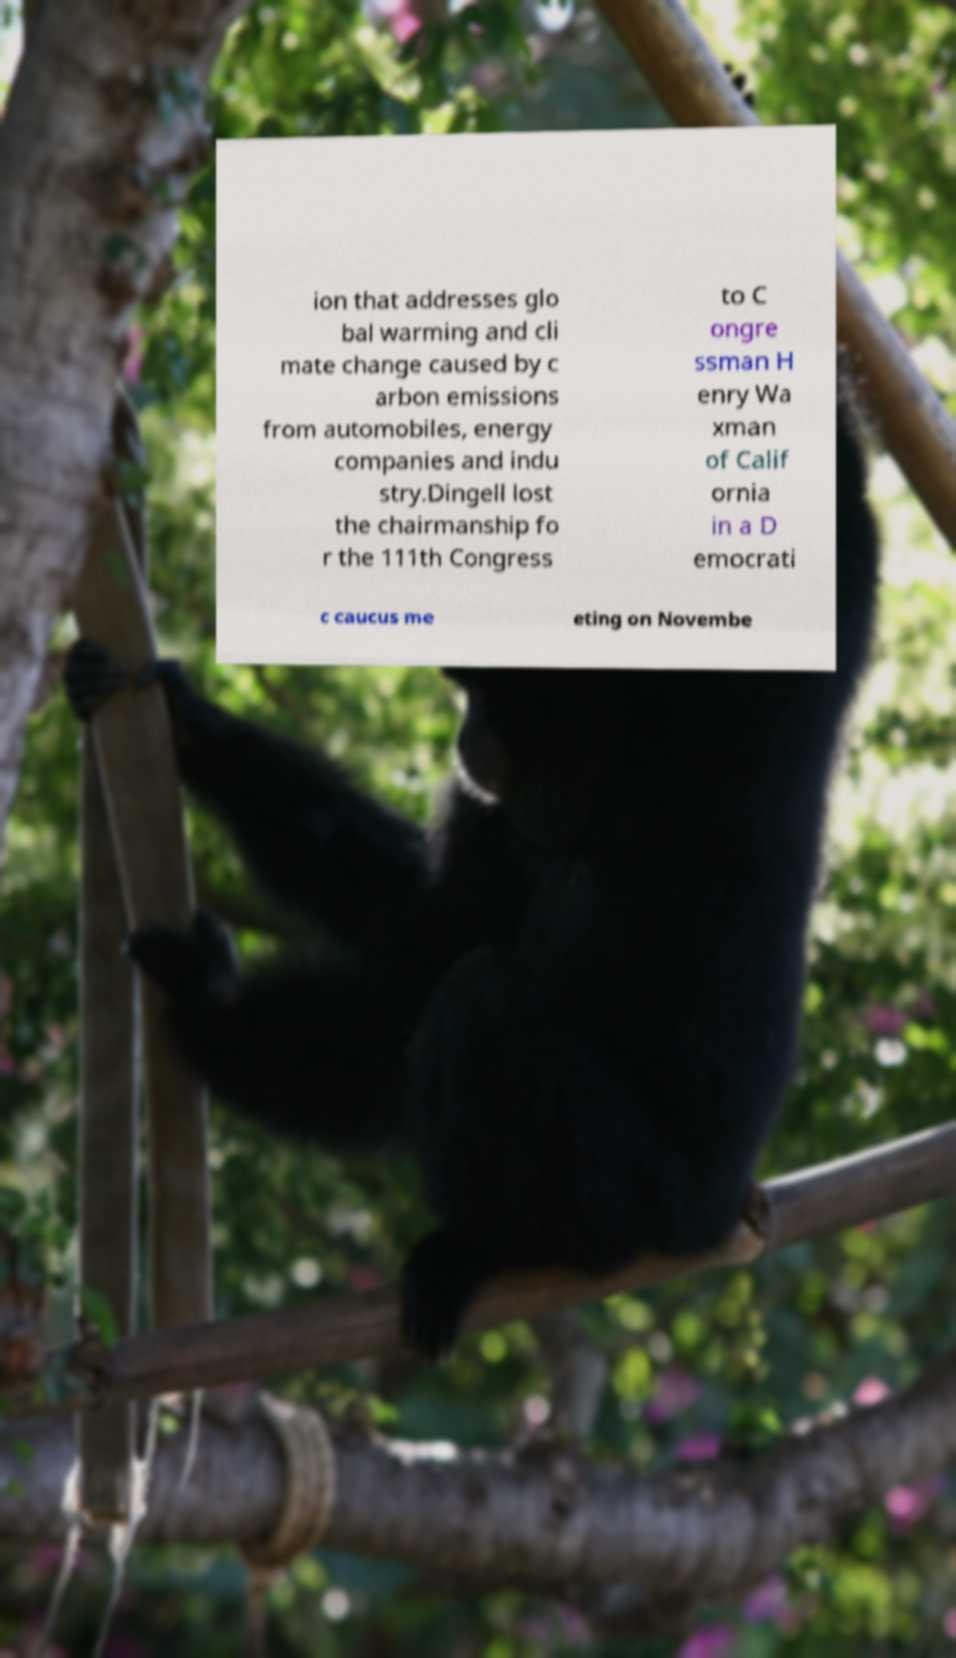I need the written content from this picture converted into text. Can you do that? ion that addresses glo bal warming and cli mate change caused by c arbon emissions from automobiles, energy companies and indu stry.Dingell lost the chairmanship fo r the 111th Congress to C ongre ssman H enry Wa xman of Calif ornia in a D emocrati c caucus me eting on Novembe 